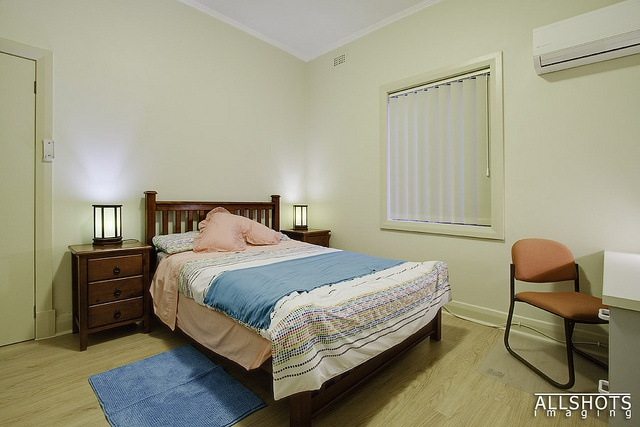Describe the objects in this image and their specific colors. I can see bed in darkgray, black, tan, and gray tones and chair in darkgray, olive, gray, and black tones in this image. 